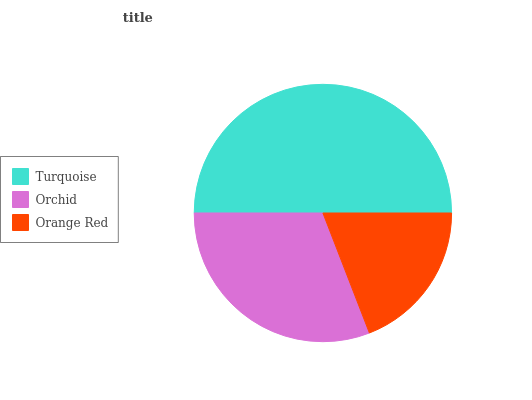Is Orange Red the minimum?
Answer yes or no. Yes. Is Turquoise the maximum?
Answer yes or no. Yes. Is Orchid the minimum?
Answer yes or no. No. Is Orchid the maximum?
Answer yes or no. No. Is Turquoise greater than Orchid?
Answer yes or no. Yes. Is Orchid less than Turquoise?
Answer yes or no. Yes. Is Orchid greater than Turquoise?
Answer yes or no. No. Is Turquoise less than Orchid?
Answer yes or no. No. Is Orchid the high median?
Answer yes or no. Yes. Is Orchid the low median?
Answer yes or no. Yes. Is Orange Red the high median?
Answer yes or no. No. Is Turquoise the low median?
Answer yes or no. No. 